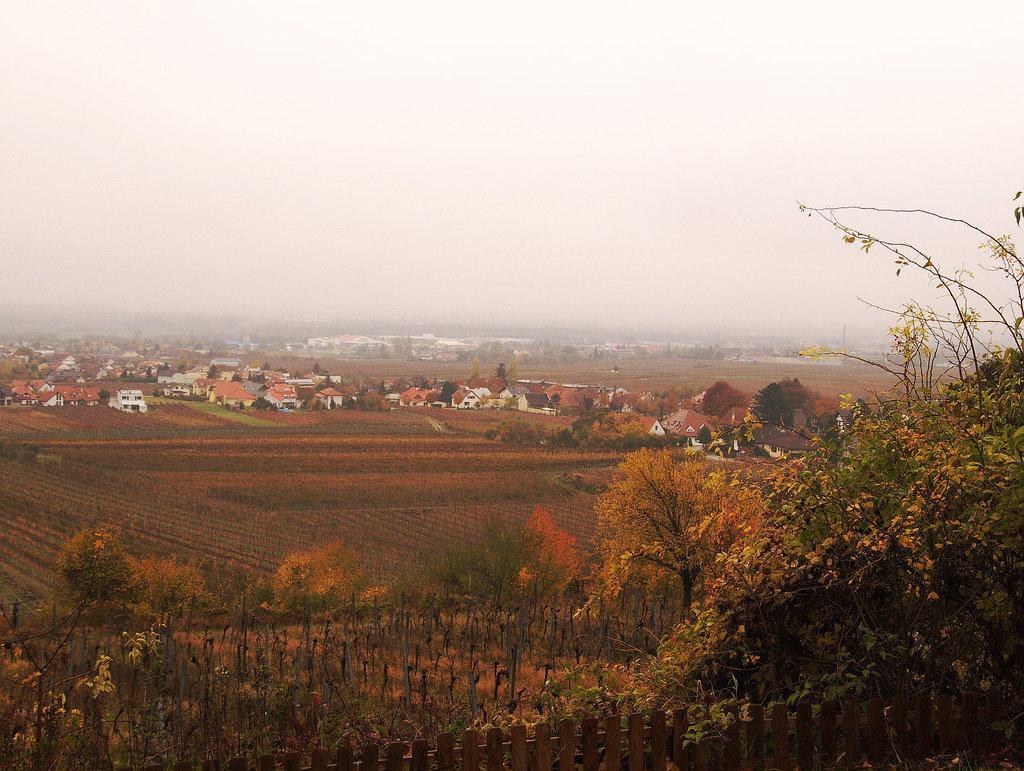Please provide a concise description of this image. These are the trees, in the middle there are houses, at the top it's a foggy sky. 